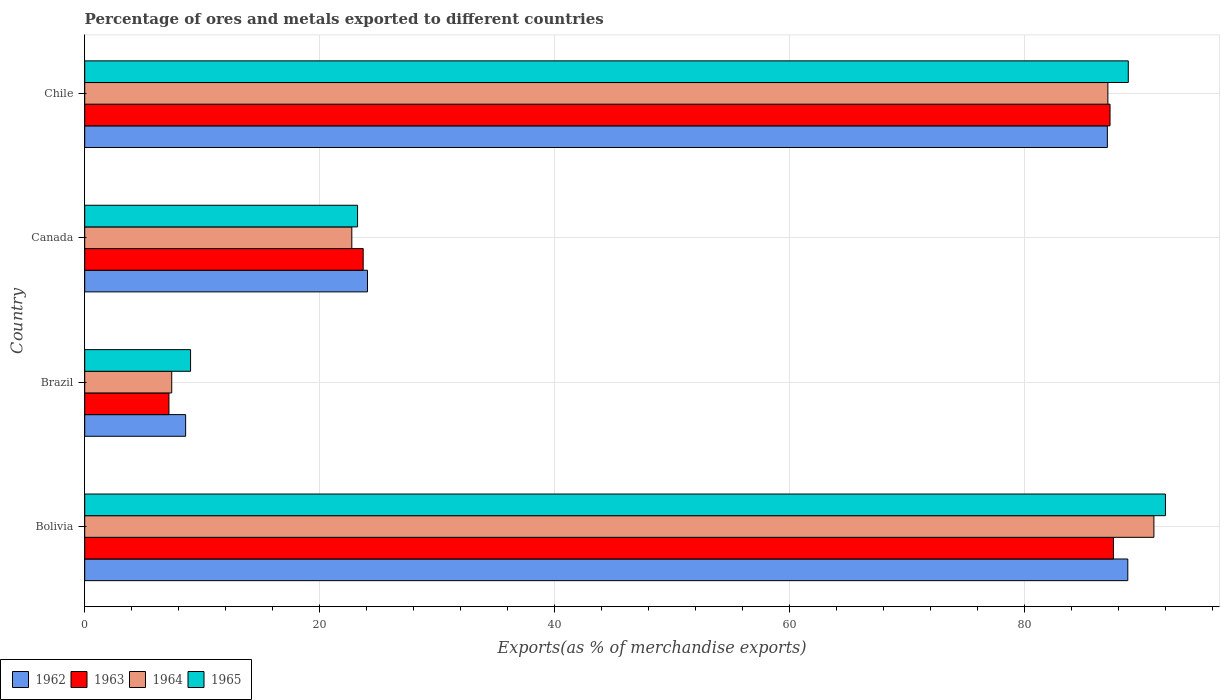How many groups of bars are there?
Ensure brevity in your answer.  4. Are the number of bars per tick equal to the number of legend labels?
Your answer should be very brief. Yes. Are the number of bars on each tick of the Y-axis equal?
Offer a very short reply. Yes. How many bars are there on the 2nd tick from the top?
Your answer should be very brief. 4. In how many cases, is the number of bars for a given country not equal to the number of legend labels?
Your answer should be very brief. 0. What is the percentage of exports to different countries in 1964 in Chile?
Offer a very short reply. 87.1. Across all countries, what is the maximum percentage of exports to different countries in 1963?
Your answer should be compact. 87.57. Across all countries, what is the minimum percentage of exports to different countries in 1963?
Offer a terse response. 7.17. In which country was the percentage of exports to different countries in 1964 minimum?
Your answer should be compact. Brazil. What is the total percentage of exports to different countries in 1965 in the graph?
Offer a very short reply. 213.07. What is the difference between the percentage of exports to different countries in 1963 in Canada and that in Chile?
Offer a very short reply. -63.58. What is the difference between the percentage of exports to different countries in 1963 in Bolivia and the percentage of exports to different countries in 1965 in Chile?
Offer a terse response. -1.27. What is the average percentage of exports to different countries in 1965 per country?
Your answer should be very brief. 53.27. What is the difference between the percentage of exports to different countries in 1962 and percentage of exports to different countries in 1963 in Brazil?
Your answer should be compact. 1.42. In how many countries, is the percentage of exports to different countries in 1963 greater than 4 %?
Your answer should be compact. 4. What is the ratio of the percentage of exports to different countries in 1962 in Brazil to that in Canada?
Your response must be concise. 0.36. Is the percentage of exports to different countries in 1964 in Canada less than that in Chile?
Your answer should be compact. Yes. Is the difference between the percentage of exports to different countries in 1962 in Bolivia and Brazil greater than the difference between the percentage of exports to different countries in 1963 in Bolivia and Brazil?
Ensure brevity in your answer.  No. What is the difference between the highest and the second highest percentage of exports to different countries in 1965?
Your response must be concise. 3.16. What is the difference between the highest and the lowest percentage of exports to different countries in 1964?
Make the answer very short. 83.61. What does the 2nd bar from the bottom in Chile represents?
Provide a short and direct response. 1963. Is it the case that in every country, the sum of the percentage of exports to different countries in 1965 and percentage of exports to different countries in 1962 is greater than the percentage of exports to different countries in 1964?
Make the answer very short. Yes. How many bars are there?
Provide a short and direct response. 16. How many countries are there in the graph?
Give a very brief answer. 4. What is the difference between two consecutive major ticks on the X-axis?
Make the answer very short. 20. Are the values on the major ticks of X-axis written in scientific E-notation?
Offer a terse response. No. Does the graph contain grids?
Your answer should be compact. Yes. How many legend labels are there?
Make the answer very short. 4. How are the legend labels stacked?
Make the answer very short. Horizontal. What is the title of the graph?
Keep it short and to the point. Percentage of ores and metals exported to different countries. What is the label or title of the X-axis?
Ensure brevity in your answer.  Exports(as % of merchandise exports). What is the label or title of the Y-axis?
Your answer should be compact. Country. What is the Exports(as % of merchandise exports) of 1962 in Bolivia?
Ensure brevity in your answer.  88.79. What is the Exports(as % of merchandise exports) in 1963 in Bolivia?
Make the answer very short. 87.57. What is the Exports(as % of merchandise exports) of 1964 in Bolivia?
Offer a very short reply. 91.02. What is the Exports(as % of merchandise exports) in 1965 in Bolivia?
Provide a succinct answer. 92. What is the Exports(as % of merchandise exports) in 1962 in Brazil?
Give a very brief answer. 8.59. What is the Exports(as % of merchandise exports) in 1963 in Brazil?
Ensure brevity in your answer.  7.17. What is the Exports(as % of merchandise exports) in 1964 in Brazil?
Give a very brief answer. 7.41. What is the Exports(as % of merchandise exports) of 1965 in Brazil?
Provide a succinct answer. 9.01. What is the Exports(as % of merchandise exports) in 1962 in Canada?
Make the answer very short. 24.07. What is the Exports(as % of merchandise exports) in 1963 in Canada?
Your answer should be compact. 23.71. What is the Exports(as % of merchandise exports) in 1964 in Canada?
Your answer should be compact. 22.74. What is the Exports(as % of merchandise exports) in 1965 in Canada?
Your response must be concise. 23.23. What is the Exports(as % of merchandise exports) in 1962 in Chile?
Ensure brevity in your answer.  87.06. What is the Exports(as % of merchandise exports) of 1963 in Chile?
Your answer should be compact. 87.28. What is the Exports(as % of merchandise exports) of 1964 in Chile?
Provide a succinct answer. 87.1. What is the Exports(as % of merchandise exports) in 1965 in Chile?
Ensure brevity in your answer.  88.84. Across all countries, what is the maximum Exports(as % of merchandise exports) of 1962?
Your answer should be very brief. 88.79. Across all countries, what is the maximum Exports(as % of merchandise exports) of 1963?
Make the answer very short. 87.57. Across all countries, what is the maximum Exports(as % of merchandise exports) of 1964?
Ensure brevity in your answer.  91.02. Across all countries, what is the maximum Exports(as % of merchandise exports) in 1965?
Give a very brief answer. 92. Across all countries, what is the minimum Exports(as % of merchandise exports) of 1962?
Provide a succinct answer. 8.59. Across all countries, what is the minimum Exports(as % of merchandise exports) of 1963?
Ensure brevity in your answer.  7.17. Across all countries, what is the minimum Exports(as % of merchandise exports) in 1964?
Provide a succinct answer. 7.41. Across all countries, what is the minimum Exports(as % of merchandise exports) in 1965?
Keep it short and to the point. 9.01. What is the total Exports(as % of merchandise exports) in 1962 in the graph?
Your response must be concise. 208.51. What is the total Exports(as % of merchandise exports) in 1963 in the graph?
Provide a short and direct response. 205.73. What is the total Exports(as % of merchandise exports) of 1964 in the graph?
Ensure brevity in your answer.  208.26. What is the total Exports(as % of merchandise exports) in 1965 in the graph?
Your answer should be very brief. 213.07. What is the difference between the Exports(as % of merchandise exports) of 1962 in Bolivia and that in Brazil?
Your answer should be compact. 80.2. What is the difference between the Exports(as % of merchandise exports) in 1963 in Bolivia and that in Brazil?
Provide a succinct answer. 80.4. What is the difference between the Exports(as % of merchandise exports) of 1964 in Bolivia and that in Brazil?
Make the answer very short. 83.61. What is the difference between the Exports(as % of merchandise exports) in 1965 in Bolivia and that in Brazil?
Make the answer very short. 82.99. What is the difference between the Exports(as % of merchandise exports) of 1962 in Bolivia and that in Canada?
Ensure brevity in your answer.  64.72. What is the difference between the Exports(as % of merchandise exports) in 1963 in Bolivia and that in Canada?
Make the answer very short. 63.86. What is the difference between the Exports(as % of merchandise exports) of 1964 in Bolivia and that in Canada?
Your answer should be compact. 68.28. What is the difference between the Exports(as % of merchandise exports) of 1965 in Bolivia and that in Canada?
Your answer should be very brief. 68.77. What is the difference between the Exports(as % of merchandise exports) in 1962 in Bolivia and that in Chile?
Give a very brief answer. 1.74. What is the difference between the Exports(as % of merchandise exports) in 1963 in Bolivia and that in Chile?
Provide a succinct answer. 0.29. What is the difference between the Exports(as % of merchandise exports) of 1964 in Bolivia and that in Chile?
Keep it short and to the point. 3.92. What is the difference between the Exports(as % of merchandise exports) in 1965 in Bolivia and that in Chile?
Offer a terse response. 3.16. What is the difference between the Exports(as % of merchandise exports) of 1962 in Brazil and that in Canada?
Your response must be concise. -15.48. What is the difference between the Exports(as % of merchandise exports) of 1963 in Brazil and that in Canada?
Your answer should be very brief. -16.54. What is the difference between the Exports(as % of merchandise exports) in 1964 in Brazil and that in Canada?
Your answer should be compact. -15.33. What is the difference between the Exports(as % of merchandise exports) in 1965 in Brazil and that in Canada?
Ensure brevity in your answer.  -14.22. What is the difference between the Exports(as % of merchandise exports) in 1962 in Brazil and that in Chile?
Your answer should be very brief. -78.46. What is the difference between the Exports(as % of merchandise exports) in 1963 in Brazil and that in Chile?
Offer a very short reply. -80.11. What is the difference between the Exports(as % of merchandise exports) in 1964 in Brazil and that in Chile?
Keep it short and to the point. -79.69. What is the difference between the Exports(as % of merchandise exports) of 1965 in Brazil and that in Chile?
Provide a short and direct response. -79.83. What is the difference between the Exports(as % of merchandise exports) of 1962 in Canada and that in Chile?
Your answer should be very brief. -62.98. What is the difference between the Exports(as % of merchandise exports) of 1963 in Canada and that in Chile?
Make the answer very short. -63.58. What is the difference between the Exports(as % of merchandise exports) in 1964 in Canada and that in Chile?
Offer a terse response. -64.36. What is the difference between the Exports(as % of merchandise exports) of 1965 in Canada and that in Chile?
Offer a very short reply. -65.61. What is the difference between the Exports(as % of merchandise exports) in 1962 in Bolivia and the Exports(as % of merchandise exports) in 1963 in Brazil?
Ensure brevity in your answer.  81.62. What is the difference between the Exports(as % of merchandise exports) in 1962 in Bolivia and the Exports(as % of merchandise exports) in 1964 in Brazil?
Offer a terse response. 81.39. What is the difference between the Exports(as % of merchandise exports) of 1962 in Bolivia and the Exports(as % of merchandise exports) of 1965 in Brazil?
Provide a short and direct response. 79.78. What is the difference between the Exports(as % of merchandise exports) of 1963 in Bolivia and the Exports(as % of merchandise exports) of 1964 in Brazil?
Ensure brevity in your answer.  80.16. What is the difference between the Exports(as % of merchandise exports) in 1963 in Bolivia and the Exports(as % of merchandise exports) in 1965 in Brazil?
Give a very brief answer. 78.56. What is the difference between the Exports(as % of merchandise exports) in 1964 in Bolivia and the Exports(as % of merchandise exports) in 1965 in Brazil?
Offer a very short reply. 82.01. What is the difference between the Exports(as % of merchandise exports) in 1962 in Bolivia and the Exports(as % of merchandise exports) in 1963 in Canada?
Your response must be concise. 65.09. What is the difference between the Exports(as % of merchandise exports) of 1962 in Bolivia and the Exports(as % of merchandise exports) of 1964 in Canada?
Keep it short and to the point. 66.06. What is the difference between the Exports(as % of merchandise exports) of 1962 in Bolivia and the Exports(as % of merchandise exports) of 1965 in Canada?
Provide a short and direct response. 65.57. What is the difference between the Exports(as % of merchandise exports) in 1963 in Bolivia and the Exports(as % of merchandise exports) in 1964 in Canada?
Give a very brief answer. 64.83. What is the difference between the Exports(as % of merchandise exports) of 1963 in Bolivia and the Exports(as % of merchandise exports) of 1965 in Canada?
Offer a terse response. 64.34. What is the difference between the Exports(as % of merchandise exports) of 1964 in Bolivia and the Exports(as % of merchandise exports) of 1965 in Canada?
Your answer should be very brief. 67.79. What is the difference between the Exports(as % of merchandise exports) of 1962 in Bolivia and the Exports(as % of merchandise exports) of 1963 in Chile?
Offer a terse response. 1.51. What is the difference between the Exports(as % of merchandise exports) in 1962 in Bolivia and the Exports(as % of merchandise exports) in 1964 in Chile?
Ensure brevity in your answer.  1.7. What is the difference between the Exports(as % of merchandise exports) in 1962 in Bolivia and the Exports(as % of merchandise exports) in 1965 in Chile?
Keep it short and to the point. -0.04. What is the difference between the Exports(as % of merchandise exports) in 1963 in Bolivia and the Exports(as % of merchandise exports) in 1964 in Chile?
Give a very brief answer. 0.47. What is the difference between the Exports(as % of merchandise exports) in 1963 in Bolivia and the Exports(as % of merchandise exports) in 1965 in Chile?
Your response must be concise. -1.27. What is the difference between the Exports(as % of merchandise exports) of 1964 in Bolivia and the Exports(as % of merchandise exports) of 1965 in Chile?
Ensure brevity in your answer.  2.18. What is the difference between the Exports(as % of merchandise exports) in 1962 in Brazil and the Exports(as % of merchandise exports) in 1963 in Canada?
Provide a succinct answer. -15.11. What is the difference between the Exports(as % of merchandise exports) in 1962 in Brazil and the Exports(as % of merchandise exports) in 1964 in Canada?
Your response must be concise. -14.15. What is the difference between the Exports(as % of merchandise exports) in 1962 in Brazil and the Exports(as % of merchandise exports) in 1965 in Canada?
Give a very brief answer. -14.64. What is the difference between the Exports(as % of merchandise exports) in 1963 in Brazil and the Exports(as % of merchandise exports) in 1964 in Canada?
Give a very brief answer. -15.57. What is the difference between the Exports(as % of merchandise exports) of 1963 in Brazil and the Exports(as % of merchandise exports) of 1965 in Canada?
Ensure brevity in your answer.  -16.06. What is the difference between the Exports(as % of merchandise exports) of 1964 in Brazil and the Exports(as % of merchandise exports) of 1965 in Canada?
Ensure brevity in your answer.  -15.82. What is the difference between the Exports(as % of merchandise exports) of 1962 in Brazil and the Exports(as % of merchandise exports) of 1963 in Chile?
Your response must be concise. -78.69. What is the difference between the Exports(as % of merchandise exports) of 1962 in Brazil and the Exports(as % of merchandise exports) of 1964 in Chile?
Give a very brief answer. -78.51. What is the difference between the Exports(as % of merchandise exports) in 1962 in Brazil and the Exports(as % of merchandise exports) in 1965 in Chile?
Your answer should be compact. -80.24. What is the difference between the Exports(as % of merchandise exports) of 1963 in Brazil and the Exports(as % of merchandise exports) of 1964 in Chile?
Make the answer very short. -79.93. What is the difference between the Exports(as % of merchandise exports) in 1963 in Brazil and the Exports(as % of merchandise exports) in 1965 in Chile?
Provide a short and direct response. -81.67. What is the difference between the Exports(as % of merchandise exports) of 1964 in Brazil and the Exports(as % of merchandise exports) of 1965 in Chile?
Your response must be concise. -81.43. What is the difference between the Exports(as % of merchandise exports) in 1962 in Canada and the Exports(as % of merchandise exports) in 1963 in Chile?
Your response must be concise. -63.21. What is the difference between the Exports(as % of merchandise exports) in 1962 in Canada and the Exports(as % of merchandise exports) in 1964 in Chile?
Keep it short and to the point. -63.03. What is the difference between the Exports(as % of merchandise exports) in 1962 in Canada and the Exports(as % of merchandise exports) in 1965 in Chile?
Keep it short and to the point. -64.76. What is the difference between the Exports(as % of merchandise exports) of 1963 in Canada and the Exports(as % of merchandise exports) of 1964 in Chile?
Your response must be concise. -63.39. What is the difference between the Exports(as % of merchandise exports) of 1963 in Canada and the Exports(as % of merchandise exports) of 1965 in Chile?
Provide a succinct answer. -65.13. What is the difference between the Exports(as % of merchandise exports) of 1964 in Canada and the Exports(as % of merchandise exports) of 1965 in Chile?
Provide a succinct answer. -66.1. What is the average Exports(as % of merchandise exports) of 1962 per country?
Offer a terse response. 52.13. What is the average Exports(as % of merchandise exports) in 1963 per country?
Make the answer very short. 51.43. What is the average Exports(as % of merchandise exports) of 1964 per country?
Your answer should be compact. 52.07. What is the average Exports(as % of merchandise exports) of 1965 per country?
Offer a very short reply. 53.27. What is the difference between the Exports(as % of merchandise exports) in 1962 and Exports(as % of merchandise exports) in 1963 in Bolivia?
Provide a succinct answer. 1.22. What is the difference between the Exports(as % of merchandise exports) of 1962 and Exports(as % of merchandise exports) of 1964 in Bolivia?
Your answer should be compact. -2.22. What is the difference between the Exports(as % of merchandise exports) in 1962 and Exports(as % of merchandise exports) in 1965 in Bolivia?
Provide a succinct answer. -3.21. What is the difference between the Exports(as % of merchandise exports) in 1963 and Exports(as % of merchandise exports) in 1964 in Bolivia?
Your answer should be very brief. -3.45. What is the difference between the Exports(as % of merchandise exports) of 1963 and Exports(as % of merchandise exports) of 1965 in Bolivia?
Provide a succinct answer. -4.43. What is the difference between the Exports(as % of merchandise exports) in 1964 and Exports(as % of merchandise exports) in 1965 in Bolivia?
Your answer should be very brief. -0.98. What is the difference between the Exports(as % of merchandise exports) of 1962 and Exports(as % of merchandise exports) of 1963 in Brazil?
Offer a very short reply. 1.42. What is the difference between the Exports(as % of merchandise exports) of 1962 and Exports(as % of merchandise exports) of 1964 in Brazil?
Offer a very short reply. 1.18. What is the difference between the Exports(as % of merchandise exports) in 1962 and Exports(as % of merchandise exports) in 1965 in Brazil?
Offer a very short reply. -0.42. What is the difference between the Exports(as % of merchandise exports) of 1963 and Exports(as % of merchandise exports) of 1964 in Brazil?
Your answer should be compact. -0.24. What is the difference between the Exports(as % of merchandise exports) of 1963 and Exports(as % of merchandise exports) of 1965 in Brazil?
Keep it short and to the point. -1.84. What is the difference between the Exports(as % of merchandise exports) in 1964 and Exports(as % of merchandise exports) in 1965 in Brazil?
Your answer should be compact. -1.6. What is the difference between the Exports(as % of merchandise exports) in 1962 and Exports(as % of merchandise exports) in 1963 in Canada?
Your response must be concise. 0.37. What is the difference between the Exports(as % of merchandise exports) of 1962 and Exports(as % of merchandise exports) of 1964 in Canada?
Offer a very short reply. 1.33. What is the difference between the Exports(as % of merchandise exports) in 1962 and Exports(as % of merchandise exports) in 1965 in Canada?
Keep it short and to the point. 0.84. What is the difference between the Exports(as % of merchandise exports) in 1963 and Exports(as % of merchandise exports) in 1964 in Canada?
Ensure brevity in your answer.  0.97. What is the difference between the Exports(as % of merchandise exports) in 1963 and Exports(as % of merchandise exports) in 1965 in Canada?
Keep it short and to the point. 0.48. What is the difference between the Exports(as % of merchandise exports) in 1964 and Exports(as % of merchandise exports) in 1965 in Canada?
Provide a succinct answer. -0.49. What is the difference between the Exports(as % of merchandise exports) of 1962 and Exports(as % of merchandise exports) of 1963 in Chile?
Provide a short and direct response. -0.23. What is the difference between the Exports(as % of merchandise exports) of 1962 and Exports(as % of merchandise exports) of 1964 in Chile?
Give a very brief answer. -0.04. What is the difference between the Exports(as % of merchandise exports) of 1962 and Exports(as % of merchandise exports) of 1965 in Chile?
Offer a terse response. -1.78. What is the difference between the Exports(as % of merchandise exports) of 1963 and Exports(as % of merchandise exports) of 1964 in Chile?
Make the answer very short. 0.18. What is the difference between the Exports(as % of merchandise exports) of 1963 and Exports(as % of merchandise exports) of 1965 in Chile?
Keep it short and to the point. -1.55. What is the difference between the Exports(as % of merchandise exports) of 1964 and Exports(as % of merchandise exports) of 1965 in Chile?
Offer a terse response. -1.74. What is the ratio of the Exports(as % of merchandise exports) in 1962 in Bolivia to that in Brazil?
Ensure brevity in your answer.  10.33. What is the ratio of the Exports(as % of merchandise exports) in 1963 in Bolivia to that in Brazil?
Keep it short and to the point. 12.21. What is the ratio of the Exports(as % of merchandise exports) of 1964 in Bolivia to that in Brazil?
Ensure brevity in your answer.  12.29. What is the ratio of the Exports(as % of merchandise exports) in 1965 in Bolivia to that in Brazil?
Your answer should be compact. 10.21. What is the ratio of the Exports(as % of merchandise exports) of 1962 in Bolivia to that in Canada?
Give a very brief answer. 3.69. What is the ratio of the Exports(as % of merchandise exports) of 1963 in Bolivia to that in Canada?
Your answer should be very brief. 3.69. What is the ratio of the Exports(as % of merchandise exports) of 1964 in Bolivia to that in Canada?
Provide a succinct answer. 4. What is the ratio of the Exports(as % of merchandise exports) in 1965 in Bolivia to that in Canada?
Keep it short and to the point. 3.96. What is the ratio of the Exports(as % of merchandise exports) of 1964 in Bolivia to that in Chile?
Offer a very short reply. 1.04. What is the ratio of the Exports(as % of merchandise exports) of 1965 in Bolivia to that in Chile?
Provide a succinct answer. 1.04. What is the ratio of the Exports(as % of merchandise exports) of 1962 in Brazil to that in Canada?
Your answer should be compact. 0.36. What is the ratio of the Exports(as % of merchandise exports) of 1963 in Brazil to that in Canada?
Your answer should be compact. 0.3. What is the ratio of the Exports(as % of merchandise exports) in 1964 in Brazil to that in Canada?
Offer a terse response. 0.33. What is the ratio of the Exports(as % of merchandise exports) in 1965 in Brazil to that in Canada?
Provide a succinct answer. 0.39. What is the ratio of the Exports(as % of merchandise exports) in 1962 in Brazil to that in Chile?
Your response must be concise. 0.1. What is the ratio of the Exports(as % of merchandise exports) in 1963 in Brazil to that in Chile?
Keep it short and to the point. 0.08. What is the ratio of the Exports(as % of merchandise exports) in 1964 in Brazil to that in Chile?
Make the answer very short. 0.09. What is the ratio of the Exports(as % of merchandise exports) in 1965 in Brazil to that in Chile?
Your answer should be compact. 0.1. What is the ratio of the Exports(as % of merchandise exports) of 1962 in Canada to that in Chile?
Your answer should be compact. 0.28. What is the ratio of the Exports(as % of merchandise exports) of 1963 in Canada to that in Chile?
Your answer should be very brief. 0.27. What is the ratio of the Exports(as % of merchandise exports) of 1964 in Canada to that in Chile?
Ensure brevity in your answer.  0.26. What is the ratio of the Exports(as % of merchandise exports) of 1965 in Canada to that in Chile?
Offer a terse response. 0.26. What is the difference between the highest and the second highest Exports(as % of merchandise exports) of 1962?
Your response must be concise. 1.74. What is the difference between the highest and the second highest Exports(as % of merchandise exports) of 1963?
Your response must be concise. 0.29. What is the difference between the highest and the second highest Exports(as % of merchandise exports) of 1964?
Make the answer very short. 3.92. What is the difference between the highest and the second highest Exports(as % of merchandise exports) in 1965?
Make the answer very short. 3.16. What is the difference between the highest and the lowest Exports(as % of merchandise exports) in 1962?
Offer a terse response. 80.2. What is the difference between the highest and the lowest Exports(as % of merchandise exports) in 1963?
Offer a terse response. 80.4. What is the difference between the highest and the lowest Exports(as % of merchandise exports) in 1964?
Your answer should be very brief. 83.61. What is the difference between the highest and the lowest Exports(as % of merchandise exports) of 1965?
Provide a short and direct response. 82.99. 